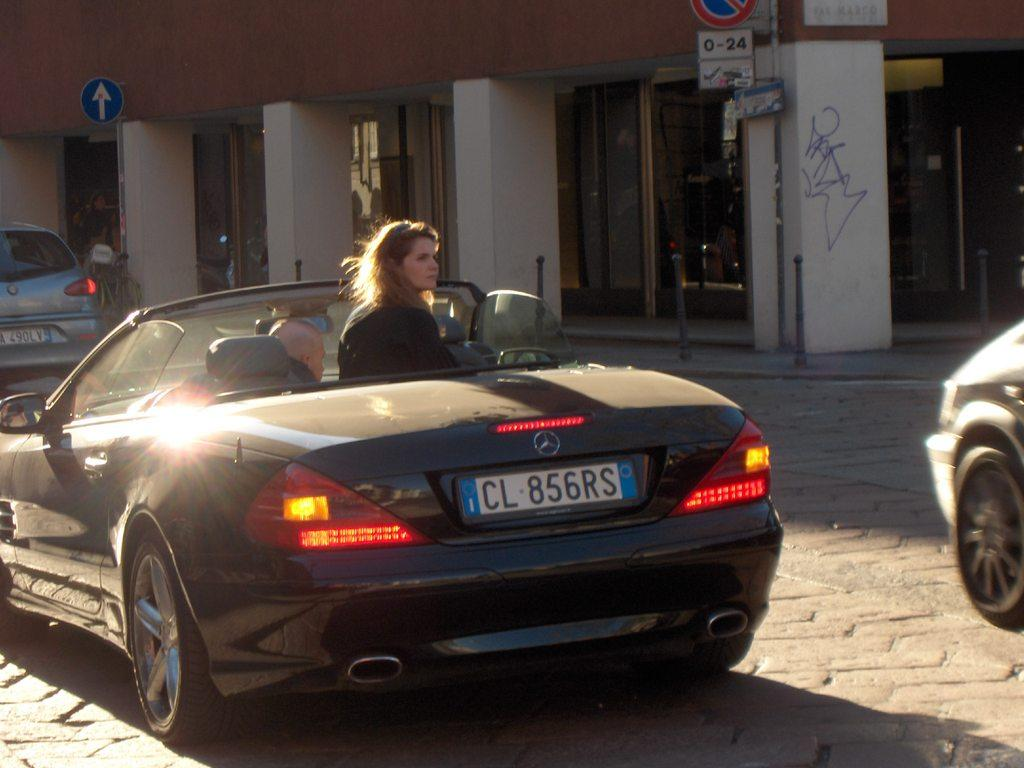What is inside the car in the image? There is a woman inside the car in the image. What can be seen in the background of the image? There are lights, a road, a building, a pillar, and a board visible in the image. Are there any other vehicles in the image besides the car? Yes, there are other vehicles in the image. What is the value of the picture in the image? There is no picture present in the image; it is a scene with a car, a woman, and other elements. 